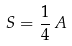<formula> <loc_0><loc_0><loc_500><loc_500>S = \frac { 1 } { 4 } \, A</formula> 